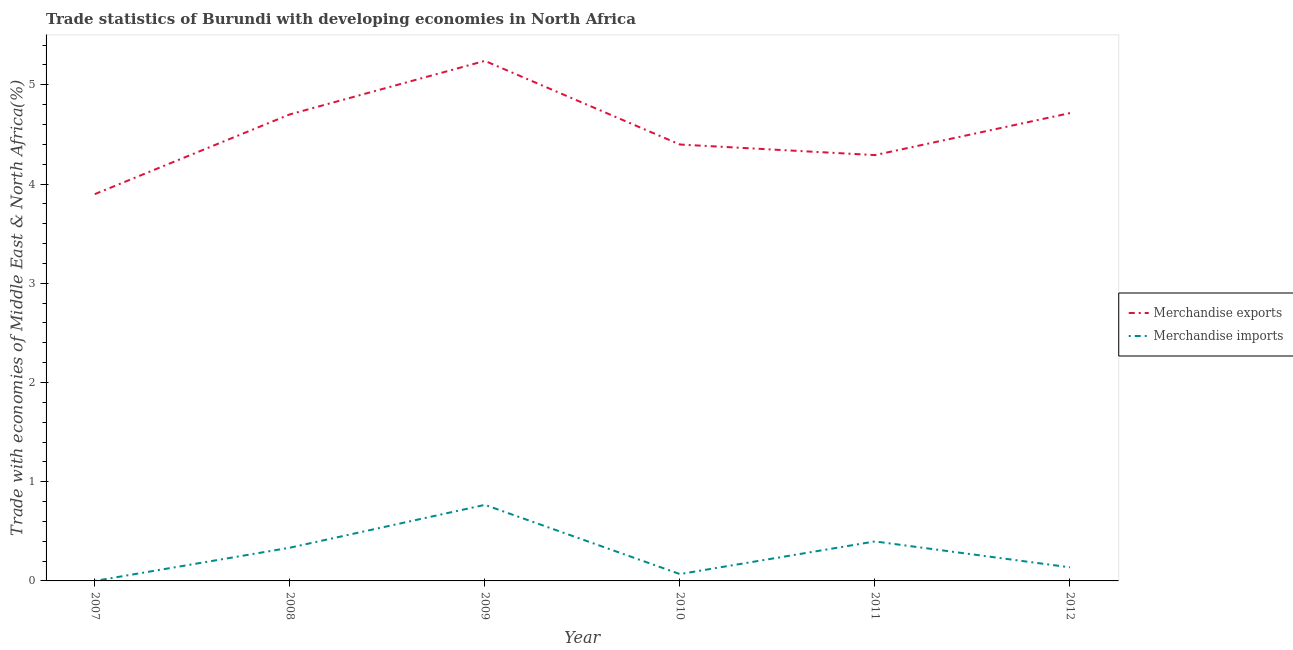How many different coloured lines are there?
Ensure brevity in your answer.  2. Is the number of lines equal to the number of legend labels?
Make the answer very short. Yes. What is the merchandise exports in 2007?
Keep it short and to the point. 3.9. Across all years, what is the maximum merchandise exports?
Provide a succinct answer. 5.24. Across all years, what is the minimum merchandise imports?
Make the answer very short. 2.88933667223069e-5. In which year was the merchandise imports maximum?
Make the answer very short. 2009. What is the total merchandise exports in the graph?
Ensure brevity in your answer.  27.24. What is the difference between the merchandise imports in 2007 and that in 2012?
Keep it short and to the point. -0.14. What is the difference between the merchandise exports in 2008 and the merchandise imports in 2009?
Ensure brevity in your answer.  3.94. What is the average merchandise imports per year?
Keep it short and to the point. 0.28. In the year 2008, what is the difference between the merchandise exports and merchandise imports?
Make the answer very short. 4.37. In how many years, is the merchandise exports greater than 5.2 %?
Offer a very short reply. 1. What is the ratio of the merchandise imports in 2011 to that in 2012?
Your answer should be very brief. 2.91. Is the merchandise imports in 2007 less than that in 2011?
Make the answer very short. Yes. Is the difference between the merchandise exports in 2009 and 2011 greater than the difference between the merchandise imports in 2009 and 2011?
Give a very brief answer. Yes. What is the difference between the highest and the second highest merchandise imports?
Give a very brief answer. 0.37. What is the difference between the highest and the lowest merchandise imports?
Make the answer very short. 0.77. How many lines are there?
Your answer should be compact. 2. How many years are there in the graph?
Make the answer very short. 6. Does the graph contain grids?
Give a very brief answer. No. What is the title of the graph?
Offer a very short reply. Trade statistics of Burundi with developing economies in North Africa. What is the label or title of the Y-axis?
Your answer should be very brief. Trade with economies of Middle East & North Africa(%). What is the Trade with economies of Middle East & North Africa(%) of Merchandise exports in 2007?
Your answer should be very brief. 3.9. What is the Trade with economies of Middle East & North Africa(%) in Merchandise imports in 2007?
Give a very brief answer. 2.88933667223069e-5. What is the Trade with economies of Middle East & North Africa(%) of Merchandise exports in 2008?
Ensure brevity in your answer.  4.7. What is the Trade with economies of Middle East & North Africa(%) in Merchandise imports in 2008?
Your response must be concise. 0.33. What is the Trade with economies of Middle East & North Africa(%) in Merchandise exports in 2009?
Offer a terse response. 5.24. What is the Trade with economies of Middle East & North Africa(%) of Merchandise imports in 2009?
Your answer should be compact. 0.77. What is the Trade with economies of Middle East & North Africa(%) in Merchandise exports in 2010?
Provide a succinct answer. 4.4. What is the Trade with economies of Middle East & North Africa(%) of Merchandise imports in 2010?
Keep it short and to the point. 0.07. What is the Trade with economies of Middle East & North Africa(%) of Merchandise exports in 2011?
Your response must be concise. 4.29. What is the Trade with economies of Middle East & North Africa(%) in Merchandise imports in 2011?
Ensure brevity in your answer.  0.4. What is the Trade with economies of Middle East & North Africa(%) in Merchandise exports in 2012?
Give a very brief answer. 4.71. What is the Trade with economies of Middle East & North Africa(%) of Merchandise imports in 2012?
Give a very brief answer. 0.14. Across all years, what is the maximum Trade with economies of Middle East & North Africa(%) of Merchandise exports?
Keep it short and to the point. 5.24. Across all years, what is the maximum Trade with economies of Middle East & North Africa(%) of Merchandise imports?
Give a very brief answer. 0.77. Across all years, what is the minimum Trade with economies of Middle East & North Africa(%) of Merchandise exports?
Keep it short and to the point. 3.9. Across all years, what is the minimum Trade with economies of Middle East & North Africa(%) of Merchandise imports?
Offer a terse response. 2.88933667223069e-5. What is the total Trade with economies of Middle East & North Africa(%) in Merchandise exports in the graph?
Your answer should be compact. 27.24. What is the total Trade with economies of Middle East & North Africa(%) of Merchandise imports in the graph?
Your response must be concise. 1.71. What is the difference between the Trade with economies of Middle East & North Africa(%) in Merchandise exports in 2007 and that in 2008?
Your answer should be compact. -0.8. What is the difference between the Trade with economies of Middle East & North Africa(%) of Merchandise imports in 2007 and that in 2008?
Your answer should be compact. -0.33. What is the difference between the Trade with economies of Middle East & North Africa(%) of Merchandise exports in 2007 and that in 2009?
Keep it short and to the point. -1.34. What is the difference between the Trade with economies of Middle East & North Africa(%) of Merchandise imports in 2007 and that in 2009?
Ensure brevity in your answer.  -0.77. What is the difference between the Trade with economies of Middle East & North Africa(%) of Merchandise imports in 2007 and that in 2010?
Make the answer very short. -0.07. What is the difference between the Trade with economies of Middle East & North Africa(%) of Merchandise exports in 2007 and that in 2011?
Your answer should be very brief. -0.39. What is the difference between the Trade with economies of Middle East & North Africa(%) of Merchandise imports in 2007 and that in 2011?
Give a very brief answer. -0.4. What is the difference between the Trade with economies of Middle East & North Africa(%) of Merchandise exports in 2007 and that in 2012?
Provide a short and direct response. -0.82. What is the difference between the Trade with economies of Middle East & North Africa(%) of Merchandise imports in 2007 and that in 2012?
Provide a succinct answer. -0.14. What is the difference between the Trade with economies of Middle East & North Africa(%) of Merchandise exports in 2008 and that in 2009?
Offer a terse response. -0.54. What is the difference between the Trade with economies of Middle East & North Africa(%) in Merchandise imports in 2008 and that in 2009?
Your answer should be compact. -0.43. What is the difference between the Trade with economies of Middle East & North Africa(%) in Merchandise exports in 2008 and that in 2010?
Ensure brevity in your answer.  0.3. What is the difference between the Trade with economies of Middle East & North Africa(%) of Merchandise imports in 2008 and that in 2010?
Make the answer very short. 0.27. What is the difference between the Trade with economies of Middle East & North Africa(%) of Merchandise exports in 2008 and that in 2011?
Make the answer very short. 0.41. What is the difference between the Trade with economies of Middle East & North Africa(%) in Merchandise imports in 2008 and that in 2011?
Offer a terse response. -0.06. What is the difference between the Trade with economies of Middle East & North Africa(%) in Merchandise exports in 2008 and that in 2012?
Provide a short and direct response. -0.01. What is the difference between the Trade with economies of Middle East & North Africa(%) of Merchandise imports in 2008 and that in 2012?
Your answer should be very brief. 0.2. What is the difference between the Trade with economies of Middle East & North Africa(%) of Merchandise exports in 2009 and that in 2010?
Provide a succinct answer. 0.84. What is the difference between the Trade with economies of Middle East & North Africa(%) in Merchandise imports in 2009 and that in 2010?
Provide a succinct answer. 0.7. What is the difference between the Trade with economies of Middle East & North Africa(%) of Merchandise exports in 2009 and that in 2011?
Ensure brevity in your answer.  0.95. What is the difference between the Trade with economies of Middle East & North Africa(%) in Merchandise imports in 2009 and that in 2011?
Your answer should be very brief. 0.37. What is the difference between the Trade with economies of Middle East & North Africa(%) in Merchandise exports in 2009 and that in 2012?
Provide a short and direct response. 0.53. What is the difference between the Trade with economies of Middle East & North Africa(%) in Merchandise imports in 2009 and that in 2012?
Your answer should be compact. 0.63. What is the difference between the Trade with economies of Middle East & North Africa(%) of Merchandise exports in 2010 and that in 2011?
Offer a very short reply. 0.11. What is the difference between the Trade with economies of Middle East & North Africa(%) of Merchandise imports in 2010 and that in 2011?
Keep it short and to the point. -0.33. What is the difference between the Trade with economies of Middle East & North Africa(%) of Merchandise exports in 2010 and that in 2012?
Offer a very short reply. -0.32. What is the difference between the Trade with economies of Middle East & North Africa(%) in Merchandise imports in 2010 and that in 2012?
Ensure brevity in your answer.  -0.07. What is the difference between the Trade with economies of Middle East & North Africa(%) of Merchandise exports in 2011 and that in 2012?
Keep it short and to the point. -0.42. What is the difference between the Trade with economies of Middle East & North Africa(%) of Merchandise imports in 2011 and that in 2012?
Offer a terse response. 0.26. What is the difference between the Trade with economies of Middle East & North Africa(%) in Merchandise exports in 2007 and the Trade with economies of Middle East & North Africa(%) in Merchandise imports in 2008?
Make the answer very short. 3.56. What is the difference between the Trade with economies of Middle East & North Africa(%) in Merchandise exports in 2007 and the Trade with economies of Middle East & North Africa(%) in Merchandise imports in 2009?
Keep it short and to the point. 3.13. What is the difference between the Trade with economies of Middle East & North Africa(%) in Merchandise exports in 2007 and the Trade with economies of Middle East & North Africa(%) in Merchandise imports in 2010?
Ensure brevity in your answer.  3.83. What is the difference between the Trade with economies of Middle East & North Africa(%) of Merchandise exports in 2007 and the Trade with economies of Middle East & North Africa(%) of Merchandise imports in 2011?
Give a very brief answer. 3.5. What is the difference between the Trade with economies of Middle East & North Africa(%) in Merchandise exports in 2007 and the Trade with economies of Middle East & North Africa(%) in Merchandise imports in 2012?
Keep it short and to the point. 3.76. What is the difference between the Trade with economies of Middle East & North Africa(%) of Merchandise exports in 2008 and the Trade with economies of Middle East & North Africa(%) of Merchandise imports in 2009?
Your answer should be compact. 3.94. What is the difference between the Trade with economies of Middle East & North Africa(%) in Merchandise exports in 2008 and the Trade with economies of Middle East & North Africa(%) in Merchandise imports in 2010?
Ensure brevity in your answer.  4.63. What is the difference between the Trade with economies of Middle East & North Africa(%) of Merchandise exports in 2008 and the Trade with economies of Middle East & North Africa(%) of Merchandise imports in 2011?
Your answer should be compact. 4.3. What is the difference between the Trade with economies of Middle East & North Africa(%) in Merchandise exports in 2008 and the Trade with economies of Middle East & North Africa(%) in Merchandise imports in 2012?
Make the answer very short. 4.56. What is the difference between the Trade with economies of Middle East & North Africa(%) of Merchandise exports in 2009 and the Trade with economies of Middle East & North Africa(%) of Merchandise imports in 2010?
Ensure brevity in your answer.  5.17. What is the difference between the Trade with economies of Middle East & North Africa(%) of Merchandise exports in 2009 and the Trade with economies of Middle East & North Africa(%) of Merchandise imports in 2011?
Your response must be concise. 4.84. What is the difference between the Trade with economies of Middle East & North Africa(%) of Merchandise exports in 2009 and the Trade with economies of Middle East & North Africa(%) of Merchandise imports in 2012?
Offer a very short reply. 5.1. What is the difference between the Trade with economies of Middle East & North Africa(%) of Merchandise exports in 2010 and the Trade with economies of Middle East & North Africa(%) of Merchandise imports in 2012?
Ensure brevity in your answer.  4.26. What is the difference between the Trade with economies of Middle East & North Africa(%) in Merchandise exports in 2011 and the Trade with economies of Middle East & North Africa(%) in Merchandise imports in 2012?
Your answer should be very brief. 4.15. What is the average Trade with economies of Middle East & North Africa(%) in Merchandise exports per year?
Provide a succinct answer. 4.54. What is the average Trade with economies of Middle East & North Africa(%) of Merchandise imports per year?
Provide a short and direct response. 0.28. In the year 2007, what is the difference between the Trade with economies of Middle East & North Africa(%) in Merchandise exports and Trade with economies of Middle East & North Africa(%) in Merchandise imports?
Provide a short and direct response. 3.9. In the year 2008, what is the difference between the Trade with economies of Middle East & North Africa(%) of Merchandise exports and Trade with economies of Middle East & North Africa(%) of Merchandise imports?
Provide a short and direct response. 4.37. In the year 2009, what is the difference between the Trade with economies of Middle East & North Africa(%) of Merchandise exports and Trade with economies of Middle East & North Africa(%) of Merchandise imports?
Your response must be concise. 4.47. In the year 2010, what is the difference between the Trade with economies of Middle East & North Africa(%) in Merchandise exports and Trade with economies of Middle East & North Africa(%) in Merchandise imports?
Provide a succinct answer. 4.33. In the year 2011, what is the difference between the Trade with economies of Middle East & North Africa(%) in Merchandise exports and Trade with economies of Middle East & North Africa(%) in Merchandise imports?
Your response must be concise. 3.89. In the year 2012, what is the difference between the Trade with economies of Middle East & North Africa(%) of Merchandise exports and Trade with economies of Middle East & North Africa(%) of Merchandise imports?
Ensure brevity in your answer.  4.58. What is the ratio of the Trade with economies of Middle East & North Africa(%) of Merchandise exports in 2007 to that in 2008?
Your answer should be compact. 0.83. What is the ratio of the Trade with economies of Middle East & North Africa(%) of Merchandise exports in 2007 to that in 2009?
Make the answer very short. 0.74. What is the ratio of the Trade with economies of Middle East & North Africa(%) in Merchandise exports in 2007 to that in 2010?
Provide a short and direct response. 0.89. What is the ratio of the Trade with economies of Middle East & North Africa(%) of Merchandise imports in 2007 to that in 2010?
Offer a terse response. 0. What is the ratio of the Trade with economies of Middle East & North Africa(%) of Merchandise exports in 2007 to that in 2011?
Provide a short and direct response. 0.91. What is the ratio of the Trade with economies of Middle East & North Africa(%) in Merchandise imports in 2007 to that in 2011?
Keep it short and to the point. 0. What is the ratio of the Trade with economies of Middle East & North Africa(%) of Merchandise exports in 2007 to that in 2012?
Provide a succinct answer. 0.83. What is the ratio of the Trade with economies of Middle East & North Africa(%) of Merchandise exports in 2008 to that in 2009?
Offer a terse response. 0.9. What is the ratio of the Trade with economies of Middle East & North Africa(%) of Merchandise imports in 2008 to that in 2009?
Make the answer very short. 0.44. What is the ratio of the Trade with economies of Middle East & North Africa(%) in Merchandise exports in 2008 to that in 2010?
Ensure brevity in your answer.  1.07. What is the ratio of the Trade with economies of Middle East & North Africa(%) of Merchandise imports in 2008 to that in 2010?
Your answer should be compact. 4.85. What is the ratio of the Trade with economies of Middle East & North Africa(%) of Merchandise exports in 2008 to that in 2011?
Give a very brief answer. 1.1. What is the ratio of the Trade with economies of Middle East & North Africa(%) in Merchandise imports in 2008 to that in 2011?
Keep it short and to the point. 0.84. What is the ratio of the Trade with economies of Middle East & North Africa(%) of Merchandise exports in 2008 to that in 2012?
Give a very brief answer. 1. What is the ratio of the Trade with economies of Middle East & North Africa(%) of Merchandise imports in 2008 to that in 2012?
Your response must be concise. 2.44. What is the ratio of the Trade with economies of Middle East & North Africa(%) of Merchandise exports in 2009 to that in 2010?
Ensure brevity in your answer.  1.19. What is the ratio of the Trade with economies of Middle East & North Africa(%) in Merchandise imports in 2009 to that in 2010?
Give a very brief answer. 11.11. What is the ratio of the Trade with economies of Middle East & North Africa(%) of Merchandise exports in 2009 to that in 2011?
Your answer should be compact. 1.22. What is the ratio of the Trade with economies of Middle East & North Africa(%) of Merchandise imports in 2009 to that in 2011?
Your response must be concise. 1.93. What is the ratio of the Trade with economies of Middle East & North Africa(%) in Merchandise exports in 2009 to that in 2012?
Offer a very short reply. 1.11. What is the ratio of the Trade with economies of Middle East & North Africa(%) in Merchandise imports in 2009 to that in 2012?
Give a very brief answer. 5.6. What is the ratio of the Trade with economies of Middle East & North Africa(%) in Merchandise exports in 2010 to that in 2011?
Your response must be concise. 1.02. What is the ratio of the Trade with economies of Middle East & North Africa(%) of Merchandise imports in 2010 to that in 2011?
Give a very brief answer. 0.17. What is the ratio of the Trade with economies of Middle East & North Africa(%) of Merchandise exports in 2010 to that in 2012?
Offer a very short reply. 0.93. What is the ratio of the Trade with economies of Middle East & North Africa(%) of Merchandise imports in 2010 to that in 2012?
Provide a short and direct response. 0.5. What is the ratio of the Trade with economies of Middle East & North Africa(%) of Merchandise exports in 2011 to that in 2012?
Provide a short and direct response. 0.91. What is the ratio of the Trade with economies of Middle East & North Africa(%) in Merchandise imports in 2011 to that in 2012?
Your response must be concise. 2.91. What is the difference between the highest and the second highest Trade with economies of Middle East & North Africa(%) in Merchandise exports?
Provide a succinct answer. 0.53. What is the difference between the highest and the second highest Trade with economies of Middle East & North Africa(%) in Merchandise imports?
Offer a very short reply. 0.37. What is the difference between the highest and the lowest Trade with economies of Middle East & North Africa(%) in Merchandise exports?
Give a very brief answer. 1.34. What is the difference between the highest and the lowest Trade with economies of Middle East & North Africa(%) in Merchandise imports?
Make the answer very short. 0.77. 